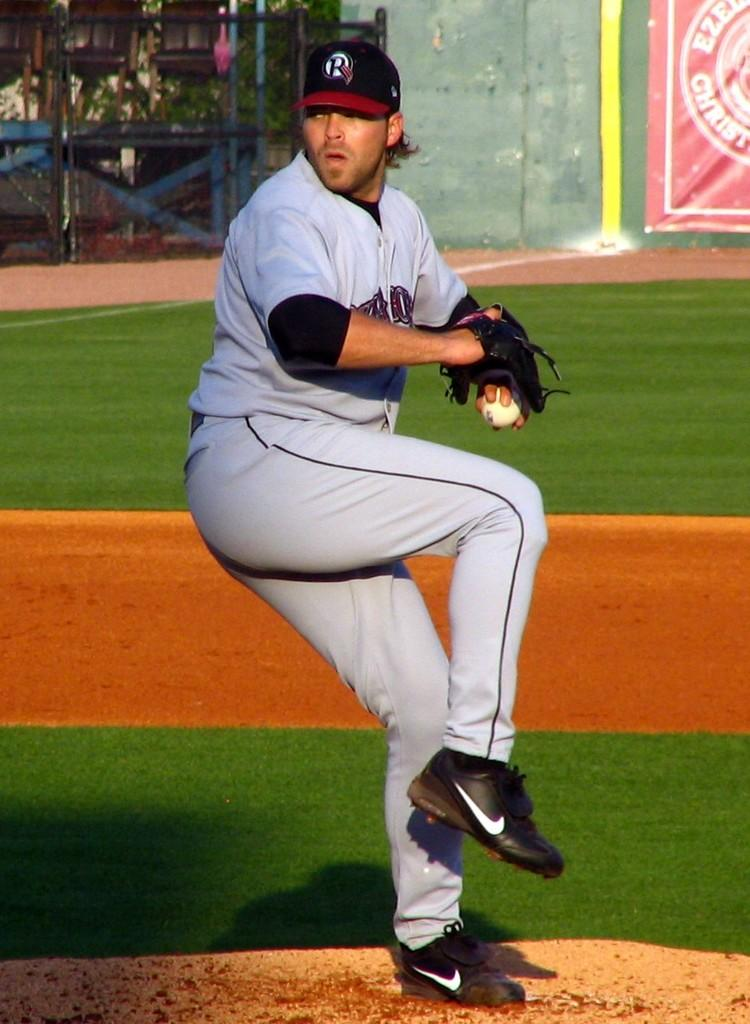Provide a one-sentence caption for the provided image. The pitcher on the mound has a Houston hat and uniform on. 